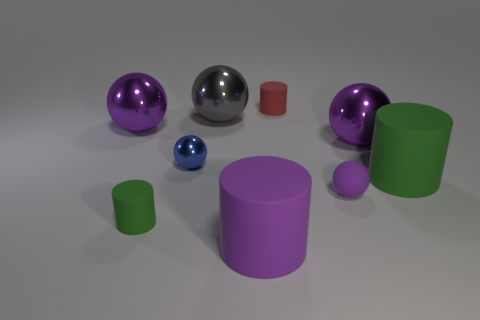There is another tiny ball that is made of the same material as the gray ball; what is its color?
Provide a short and direct response. Blue. What is the material of the big object to the right of the purple shiny sphere in front of the purple sphere on the left side of the large purple cylinder?
Make the answer very short. Rubber. Is the size of the cylinder behind the gray object the same as the small blue ball?
Offer a very short reply. Yes. What number of tiny things are matte objects or matte balls?
Offer a terse response. 3. Is there a tiny matte object that has the same color as the small shiny object?
Provide a short and direct response. No. What is the shape of the green matte thing that is the same size as the gray shiny sphere?
Your answer should be compact. Cylinder. Is the color of the small rubber object that is left of the small blue metallic thing the same as the small metal thing?
Offer a very short reply. No. What number of objects are big purple shiny things on the right side of the large purple matte thing or small red metal cylinders?
Make the answer very short. 1. Are there more red cylinders to the right of the tiny blue thing than tiny red matte things that are in front of the tiny red cylinder?
Make the answer very short. Yes. Are the small green object and the red cylinder made of the same material?
Provide a succinct answer. Yes. 